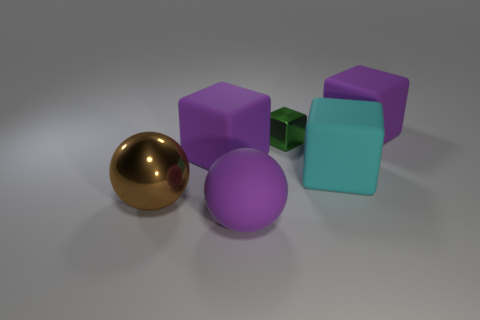How many other objects are there of the same size as the cyan rubber object?
Give a very brief answer. 4. What is the shape of the green shiny object?
Keep it short and to the point. Cube. Do the cube on the left side of the tiny shiny object and the brown ball in front of the green thing have the same material?
Your answer should be very brief. No. What number of rubber things are the same color as the matte ball?
Give a very brief answer. 2. What is the shape of the rubber thing that is both in front of the tiny green block and on the right side of the small green thing?
Give a very brief answer. Cube. There is a object that is both in front of the big cyan rubber object and right of the large brown sphere; what color is it?
Provide a short and direct response. Purple. Is the number of balls that are in front of the green metallic object greater than the number of purple matte blocks in front of the brown ball?
Give a very brief answer. Yes. There is a ball that is left of the large purple sphere; what is its color?
Give a very brief answer. Brown. There is a large purple object behind the green metallic block; does it have the same shape as the green thing right of the brown object?
Keep it short and to the point. Yes. Are there any matte things that have the same size as the brown metallic sphere?
Your response must be concise. Yes. 